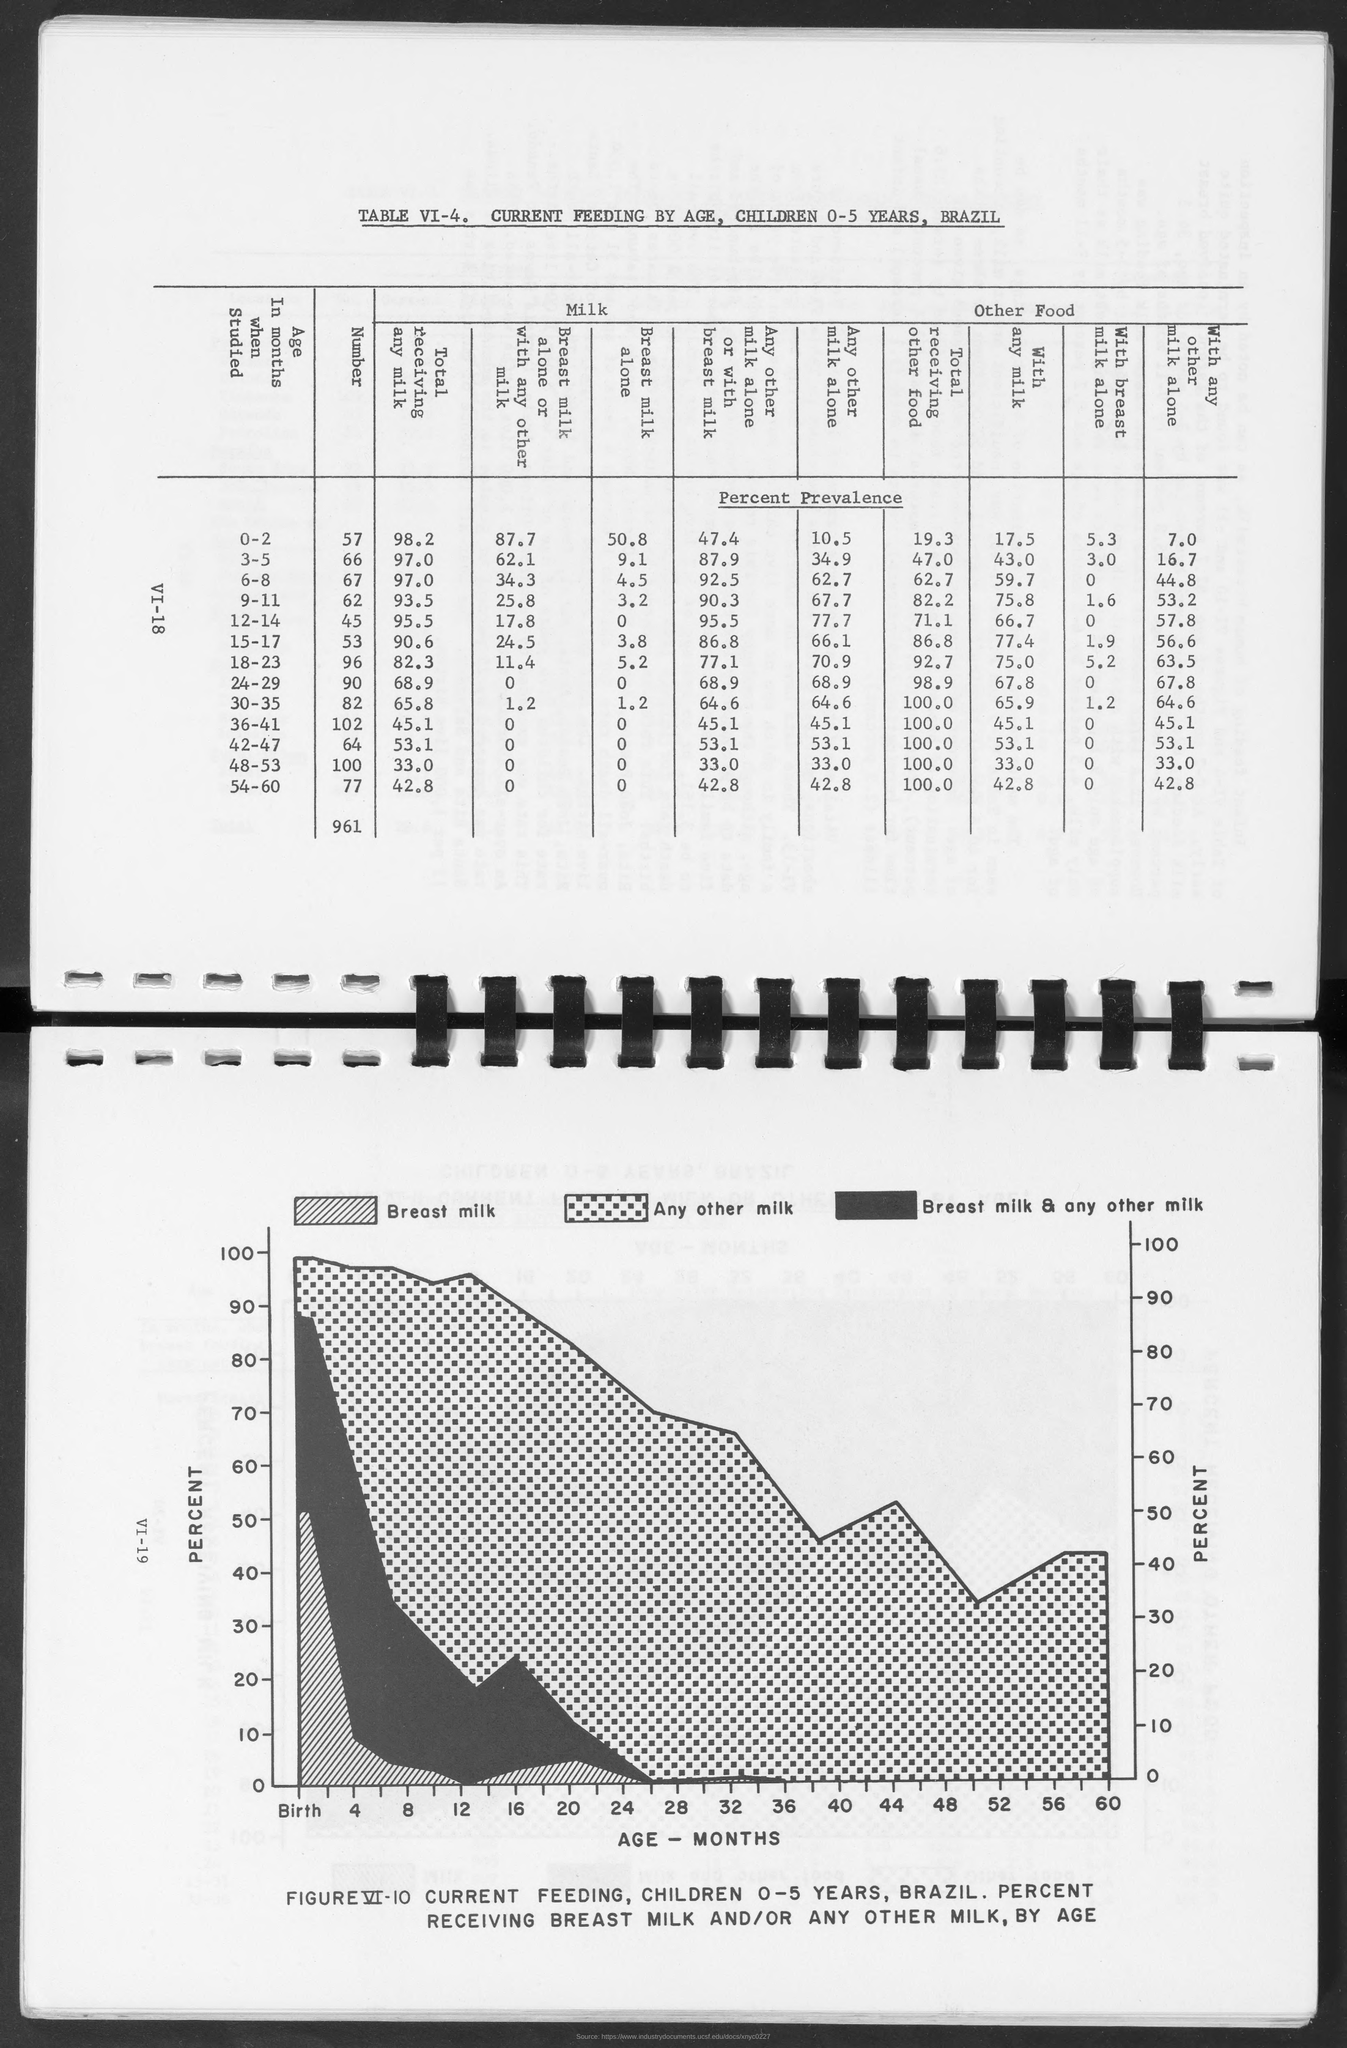Point out several critical features in this image. The y-axis of the graph represents the percentage of the total score obtained by the top three highest scores in each category. 